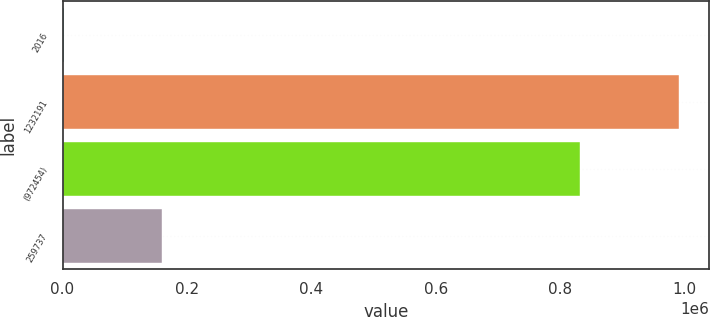<chart> <loc_0><loc_0><loc_500><loc_500><bar_chart><fcel>2016<fcel>1232191<fcel>(972454)<fcel>259737<nl><fcel>2015<fcel>990172<fcel>830898<fcel>159274<nl></chart> 